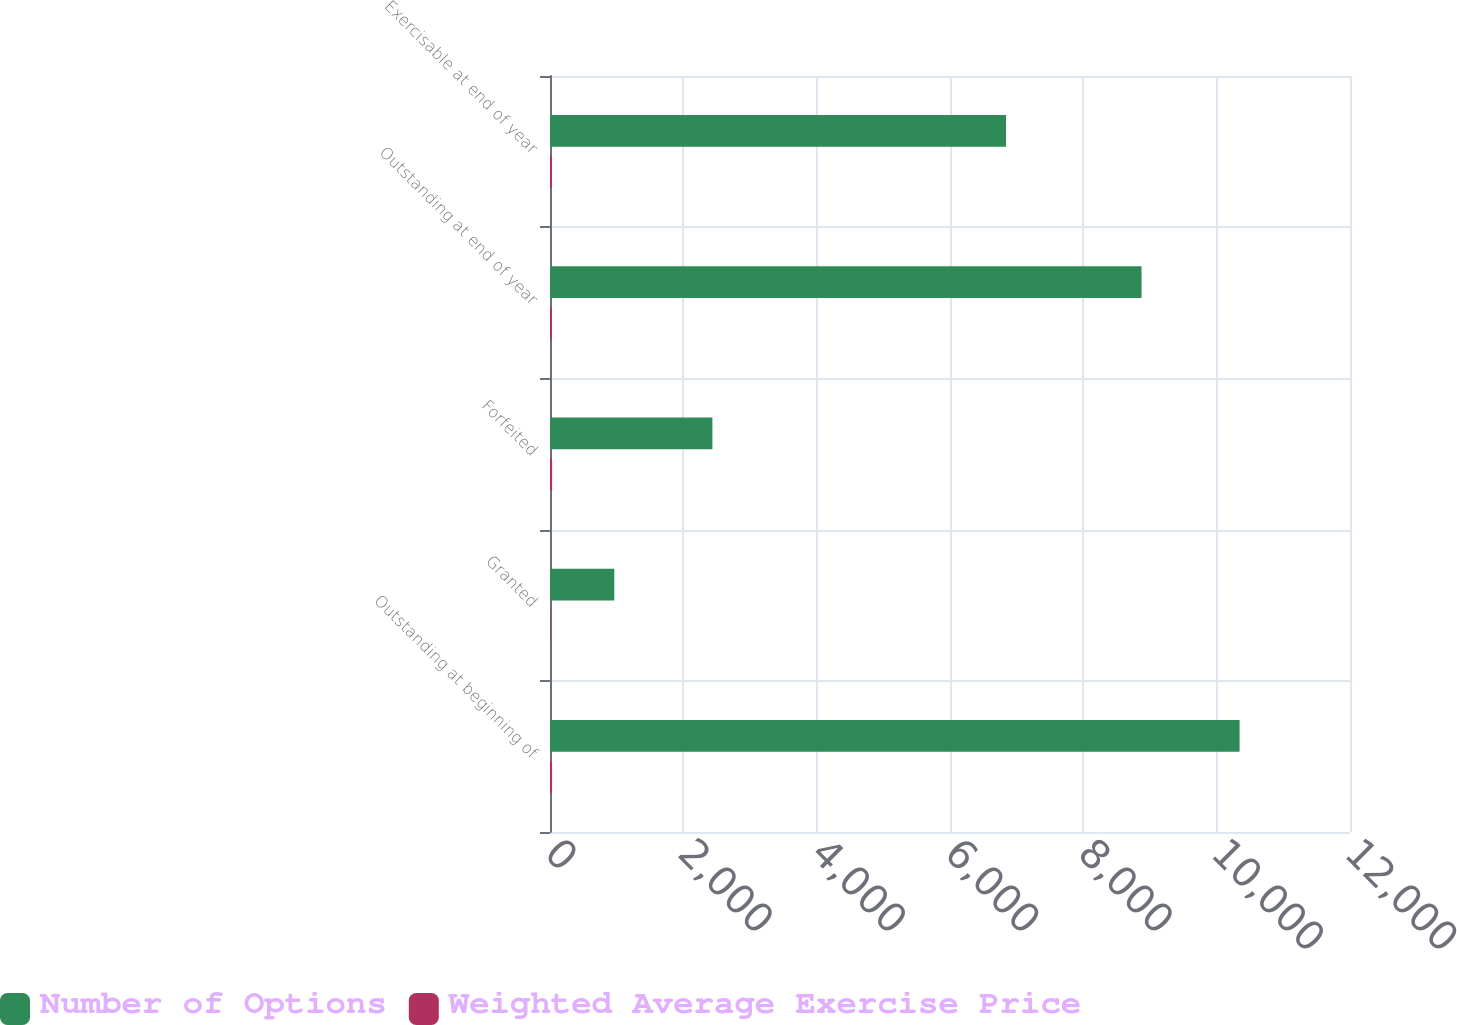Convert chart to OTSL. <chart><loc_0><loc_0><loc_500><loc_500><stacked_bar_chart><ecel><fcel>Outstanding at beginning of<fcel>Granted<fcel>Forfeited<fcel>Outstanding at end of year<fcel>Exercisable at end of year<nl><fcel>Number of Options<fcel>10344<fcel>965<fcel>2436<fcel>8873<fcel>6840<nl><fcel>Weighted Average Exercise Price<fcel>31.01<fcel>8.92<fcel>32.03<fcel>28.22<fcel>29.65<nl></chart> 